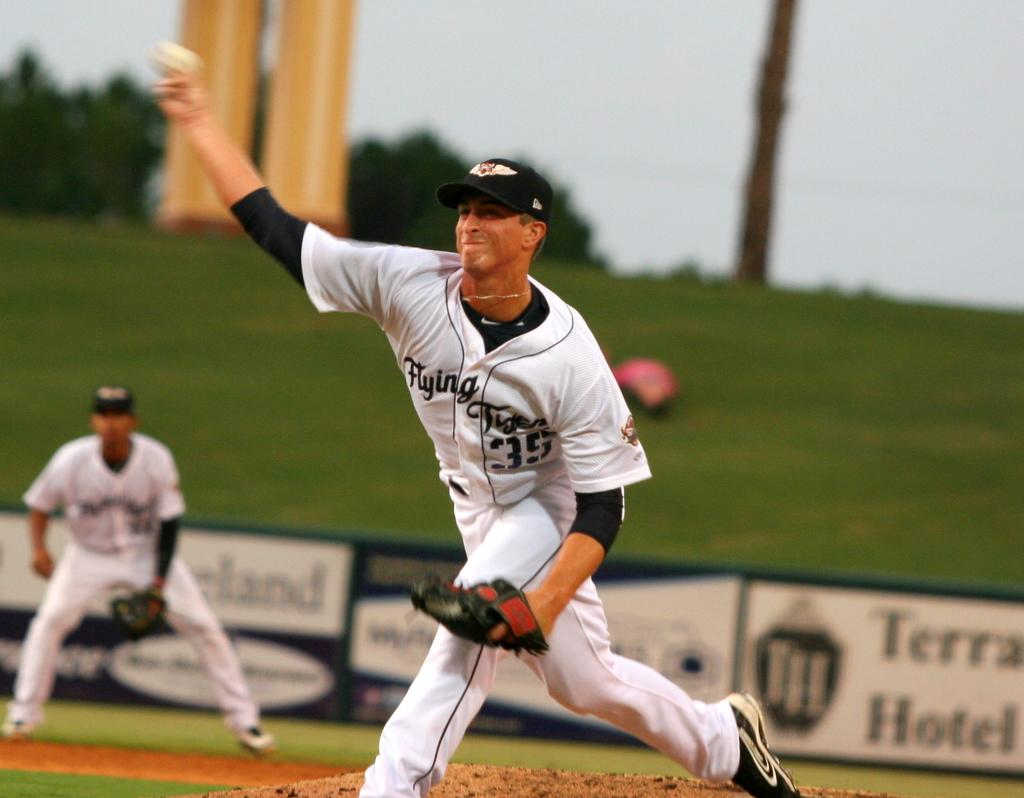<image>
Write a terse but informative summary of the picture. A baseball player in black and white has the logo for the flying tigers on his chest. 